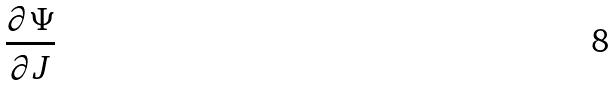Convert formula to latex. <formula><loc_0><loc_0><loc_500><loc_500>\frac { \partial \Psi } { \partial J }</formula> 